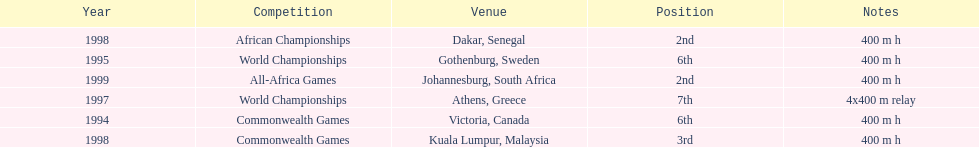What was the venue before dakar, senegal? Kuala Lumpur, Malaysia. 